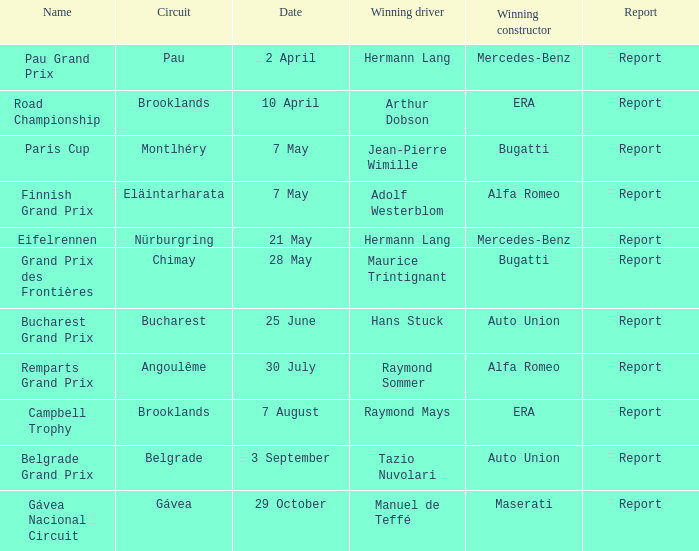Can you provide the name of the driver who won the pau grand prix? Hermann Lang. 